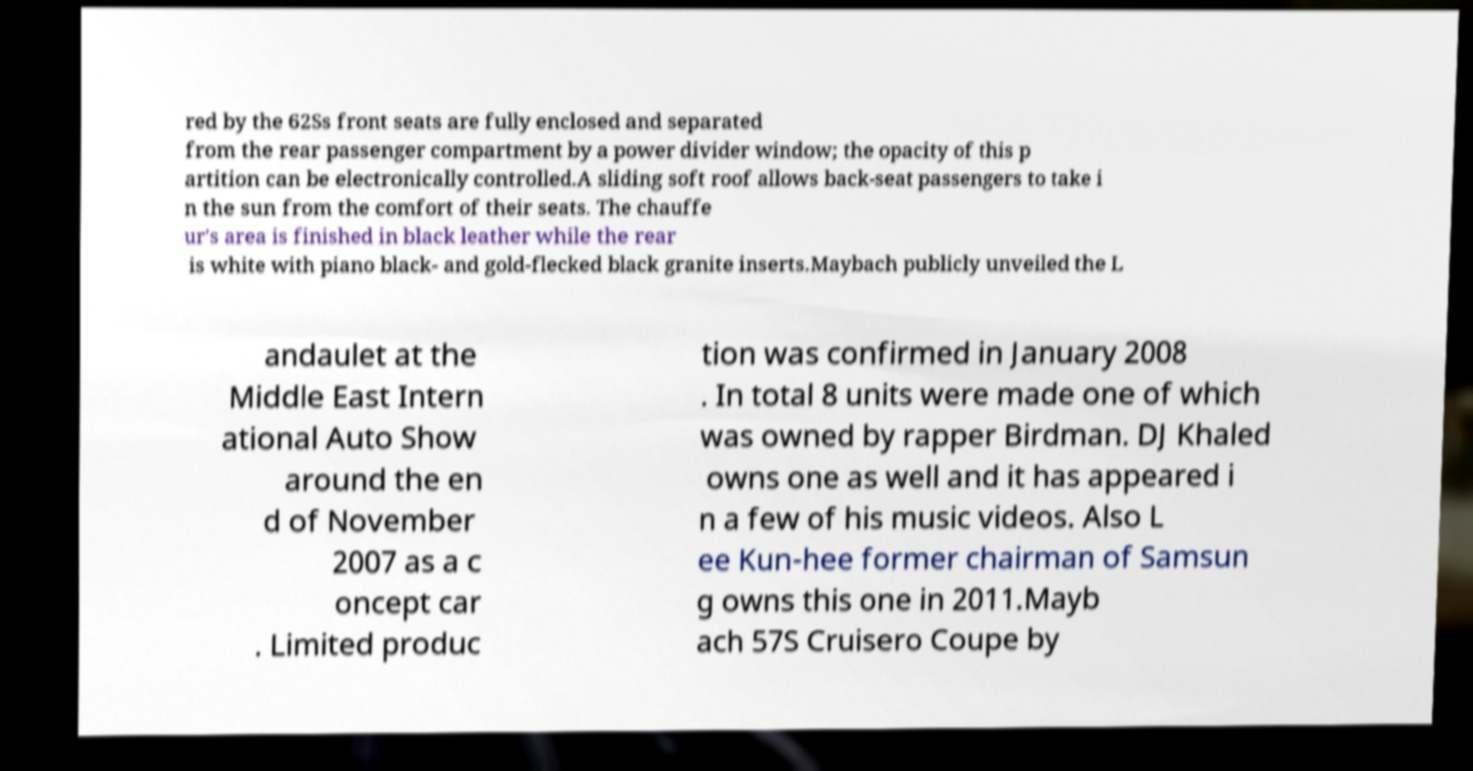Can you accurately transcribe the text from the provided image for me? red by the 62Ss front seats are fully enclosed and separated from the rear passenger compartment by a power divider window; the opacity of this p artition can be electronically controlled.A sliding soft roof allows back-seat passengers to take i n the sun from the comfort of their seats. The chauffe ur's area is finished in black leather while the rear is white with piano black- and gold-flecked black granite inserts.Maybach publicly unveiled the L andaulet at the Middle East Intern ational Auto Show around the en d of November 2007 as a c oncept car . Limited produc tion was confirmed in January 2008 . In total 8 units were made one of which was owned by rapper Birdman. DJ Khaled owns one as well and it has appeared i n a few of his music videos. Also L ee Kun-hee former chairman of Samsun g owns this one in 2011.Mayb ach 57S Cruisero Coupe by 